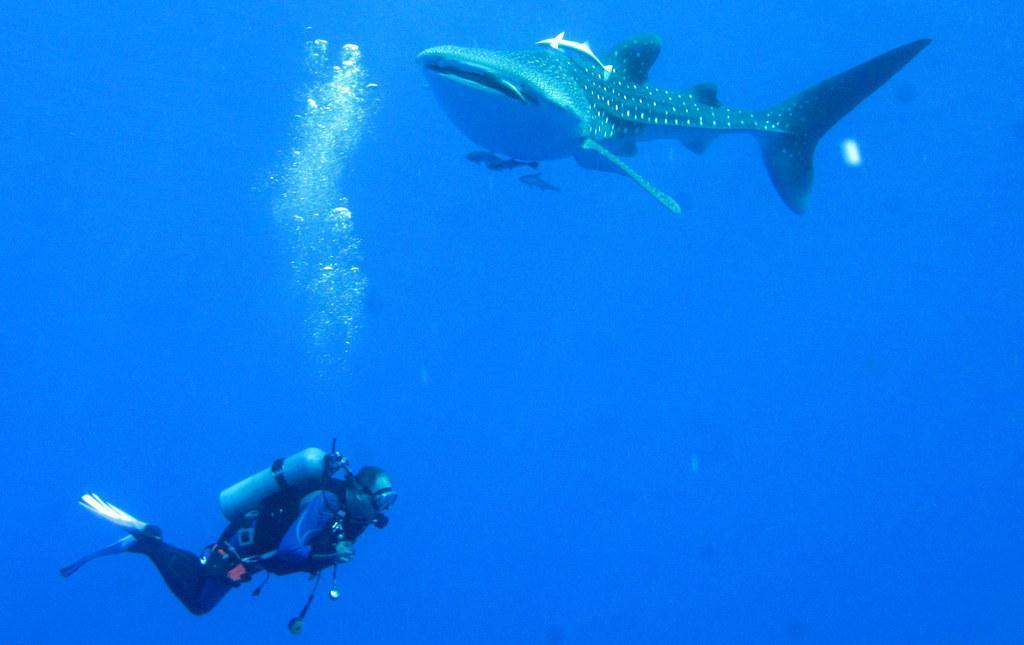How would you summarize this image in a sentence or two? At the bottom of this image, there is a person having a cylinder on the back and swimming in the water. At the top of this image, there are bubbles and fishes in the water. And the background is blue in color. 